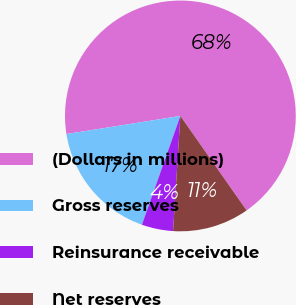Convert chart to OTSL. <chart><loc_0><loc_0><loc_500><loc_500><pie_chart><fcel>(Dollars in millions)<fcel>Gross reserves<fcel>Reinsurance receivable<fcel>Net reserves<nl><fcel>67.79%<fcel>17.08%<fcel>4.4%<fcel>10.74%<nl></chart> 